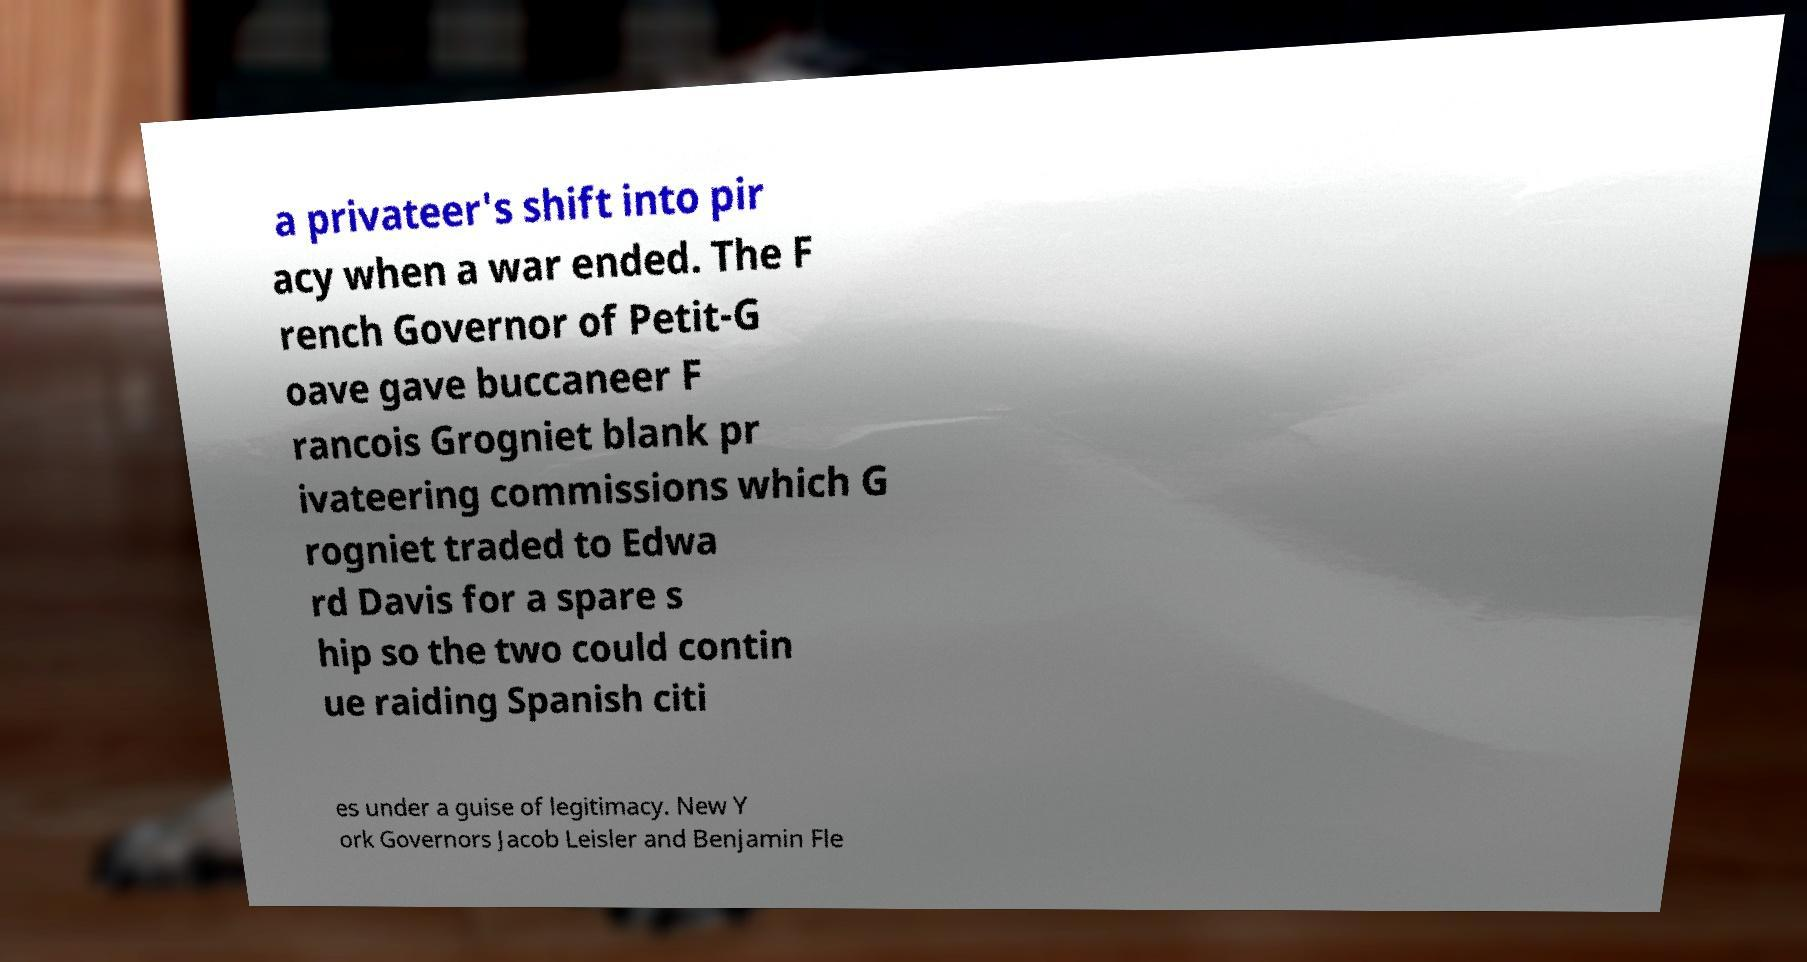Could you extract and type out the text from this image? a privateer's shift into pir acy when a war ended. The F rench Governor of Petit-G oave gave buccaneer F rancois Grogniet blank pr ivateering commissions which G rogniet traded to Edwa rd Davis for a spare s hip so the two could contin ue raiding Spanish citi es under a guise of legitimacy. New Y ork Governors Jacob Leisler and Benjamin Fle 